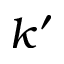Convert formula to latex. <formula><loc_0><loc_0><loc_500><loc_500>k ^ { \prime }</formula> 